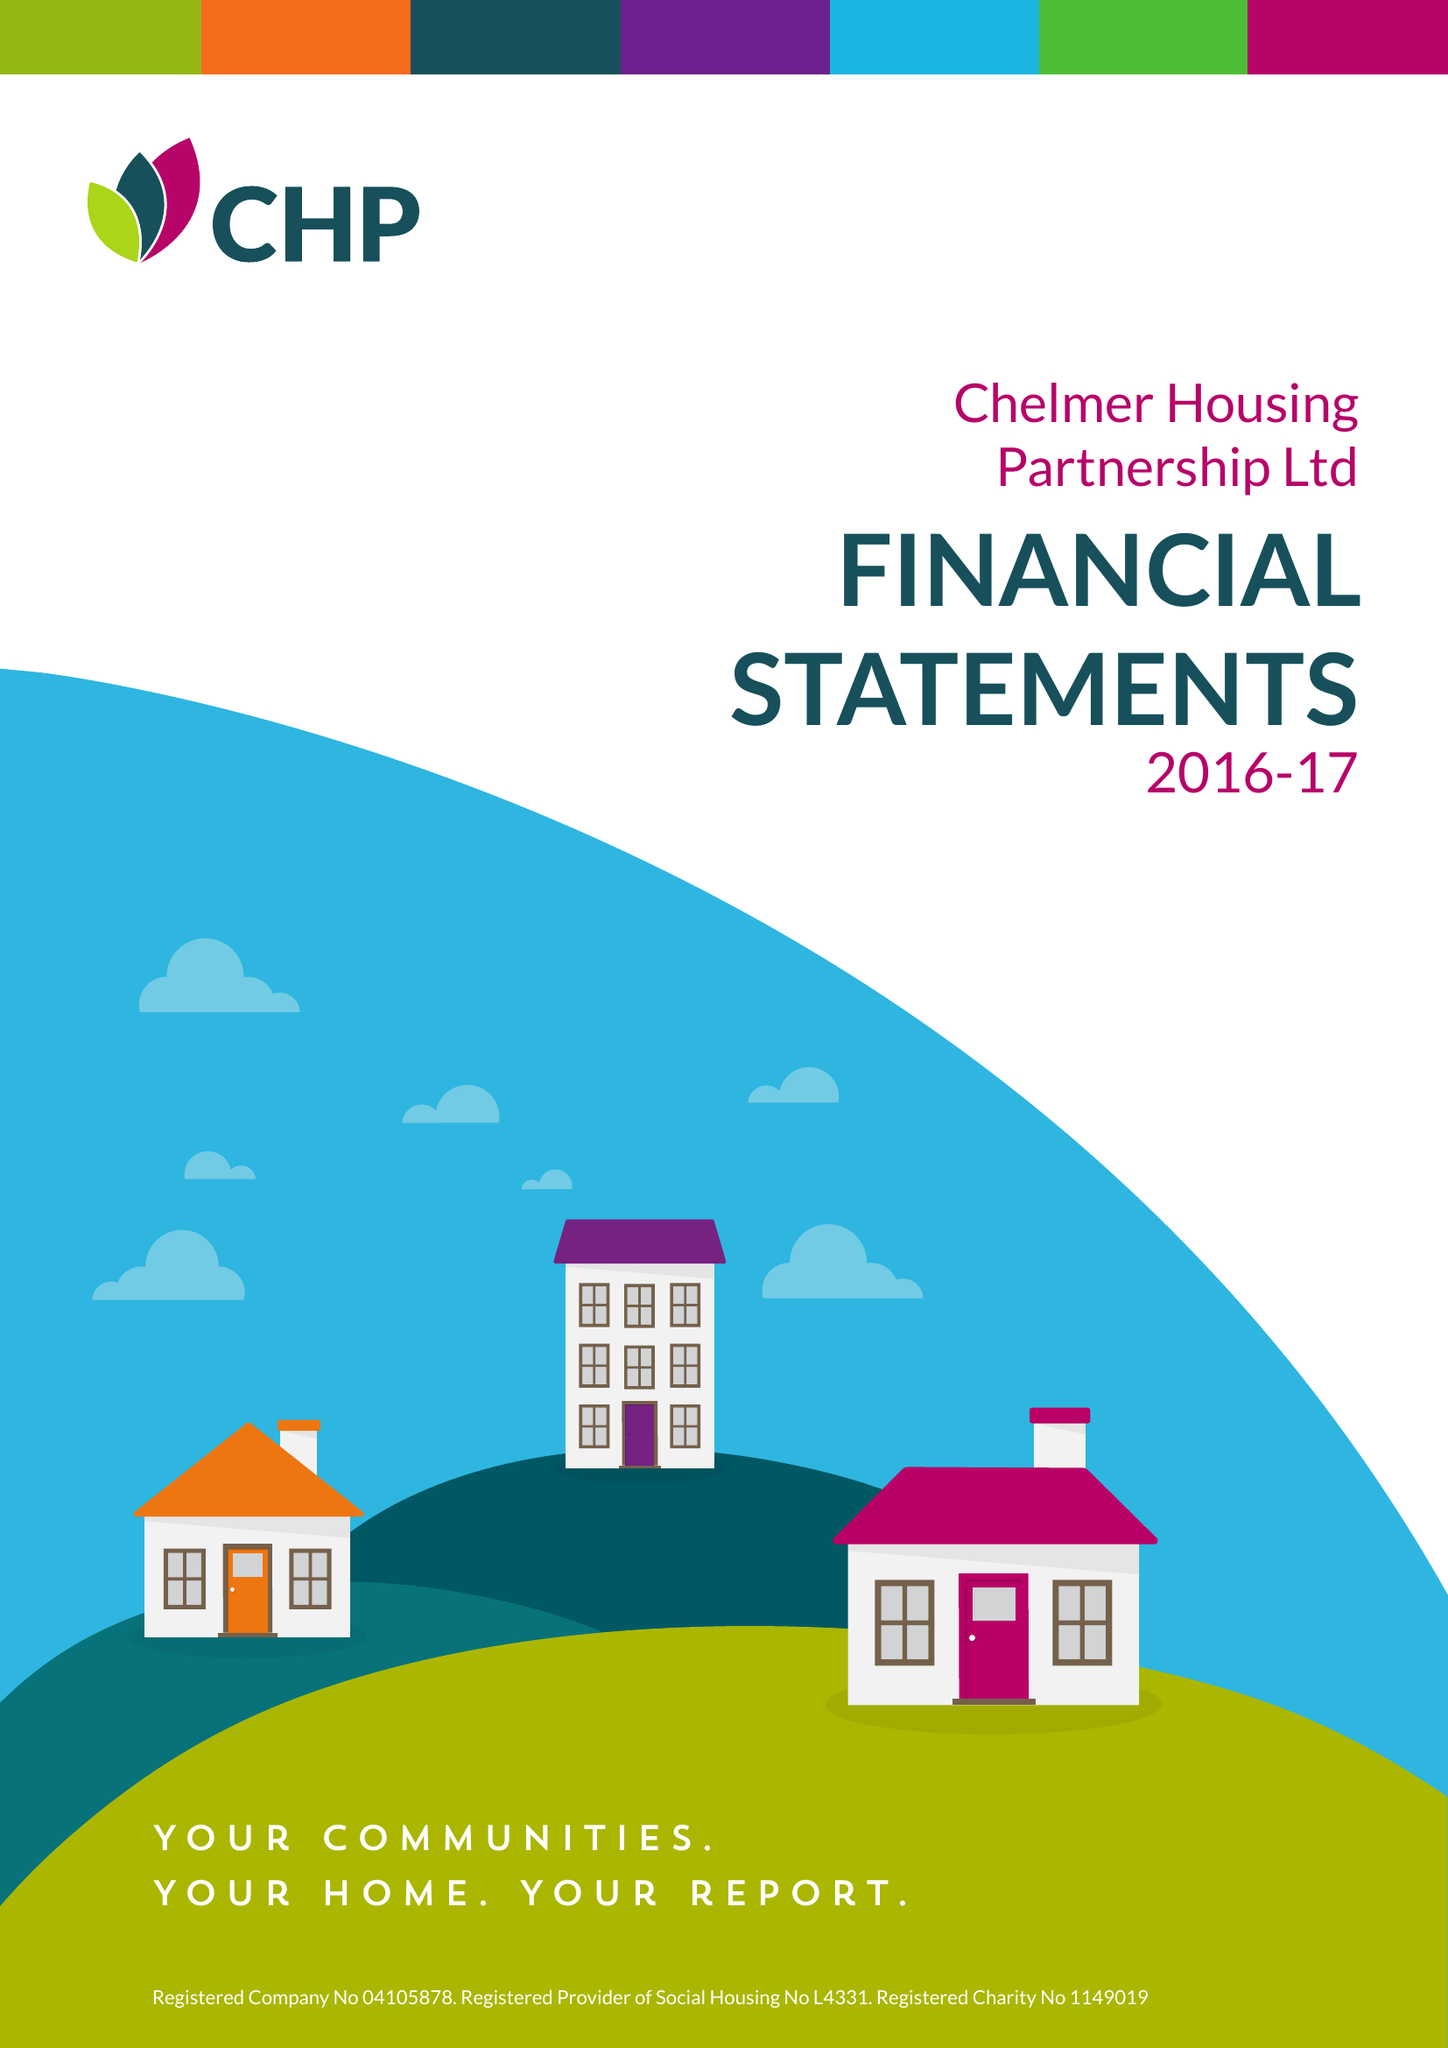What is the value for the report_date?
Answer the question using a single word or phrase. 2017-03-31 